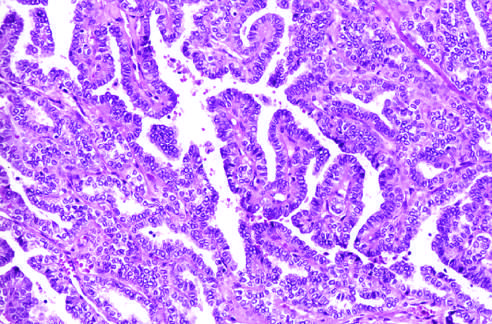what are well-formed papillae lined by?
Answer the question using a single word or phrase. Cells with characteristic empty-appearing nuclei 